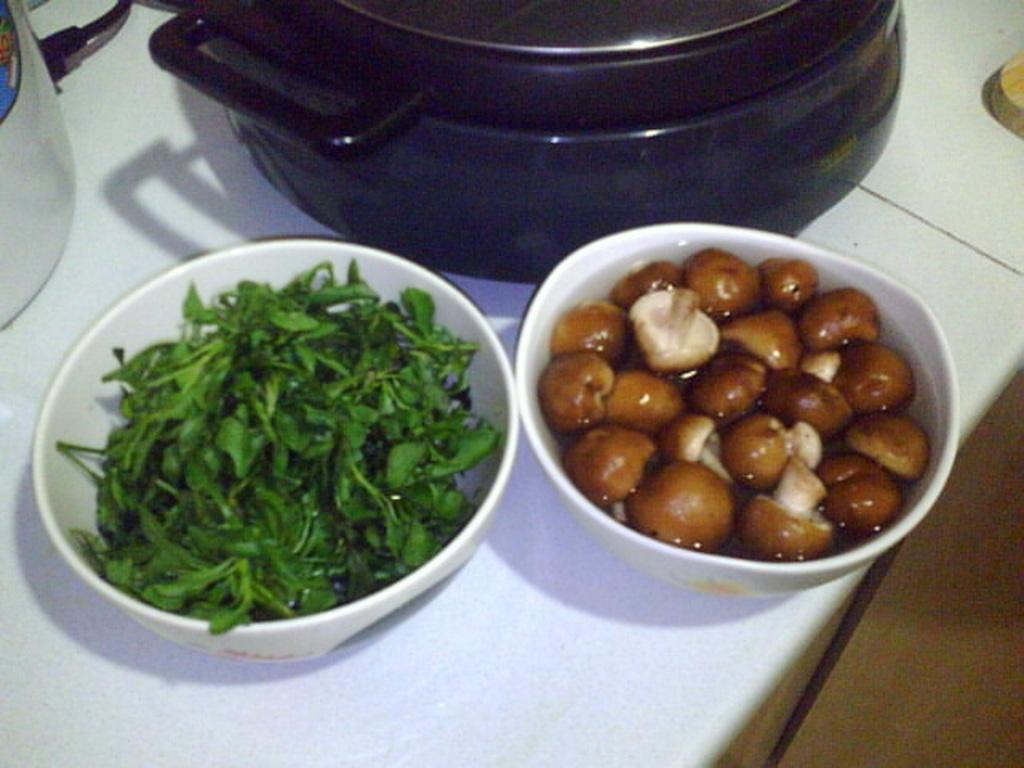What type of food is in the bowl on the left side of the image? There are mushrooms in a bowl in the image. What type of food is in the bowl on the right side of the image? There are leafy vegetables in another bowl in the image. How many dishes can be seen on the kitchen platform in the image? There are two dishes on the kitchen platform in the image. What date is circled on the calendar in the image? There is no calendar present in the image. How do the giants interact with the mushrooms in the image? There are no giants present in the image, and therefore no interaction with the mushrooms can be observed. 